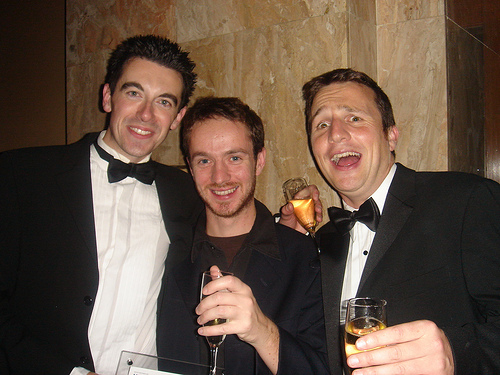<image>
Is the second head on the shoulder? Yes. Looking at the image, I can see the second head is positioned on top of the shoulder, with the shoulder providing support. 